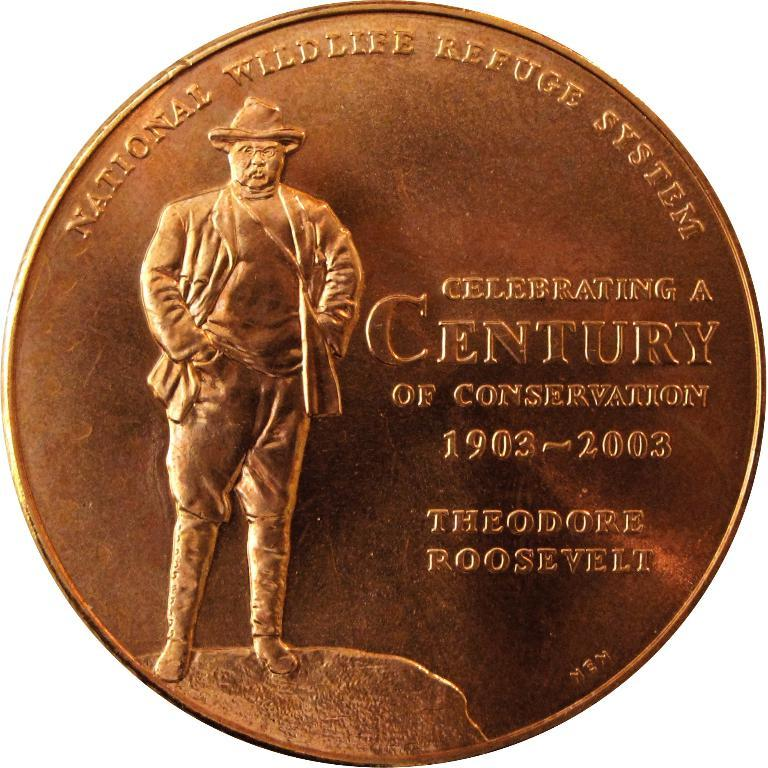<image>
Offer a succinct explanation of the picture presented. A special edition coin made for Theodore Roosevelt showing the President standing on a hill. 